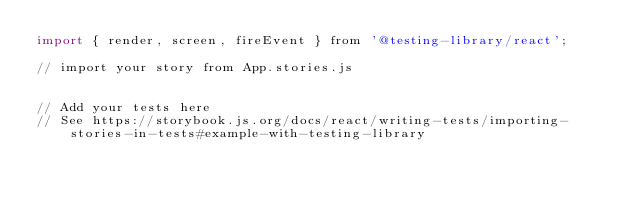<code> <loc_0><loc_0><loc_500><loc_500><_JavaScript_>import { render, screen, fireEvent } from '@testing-library/react';

// import your story from App.stories.js


// Add your tests here
// See https://storybook.js.org/docs/react/writing-tests/importing-stories-in-tests#example-with-testing-library</code> 